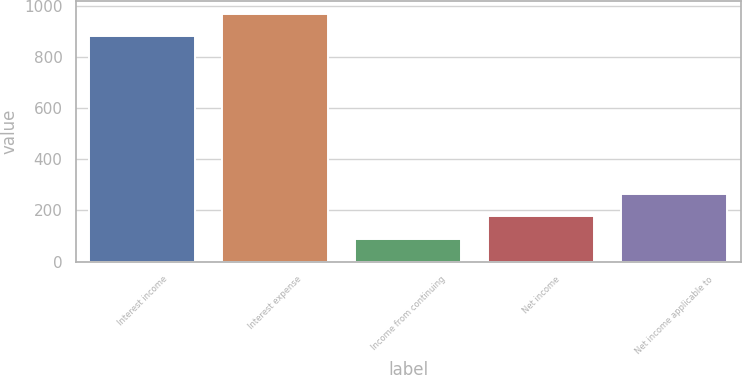<chart> <loc_0><loc_0><loc_500><loc_500><bar_chart><fcel>Interest income<fcel>Interest expense<fcel>Income from continuing<fcel>Net income<fcel>Net income applicable to<nl><fcel>882<fcel>970.1<fcel>89.1<fcel>177.2<fcel>265.3<nl></chart> 